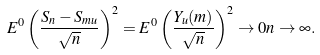Convert formula to latex. <formula><loc_0><loc_0><loc_500><loc_500>E ^ { 0 } \left ( \frac { S _ { n } - S _ { m u } } { \sqrt { n } } \right ) ^ { 2 } = E ^ { 0 } \left ( \frac { Y _ { u } ( m ) } { \sqrt { n } } \right ) ^ { 2 } \rightarrow 0 n \rightarrow \infty .</formula> 